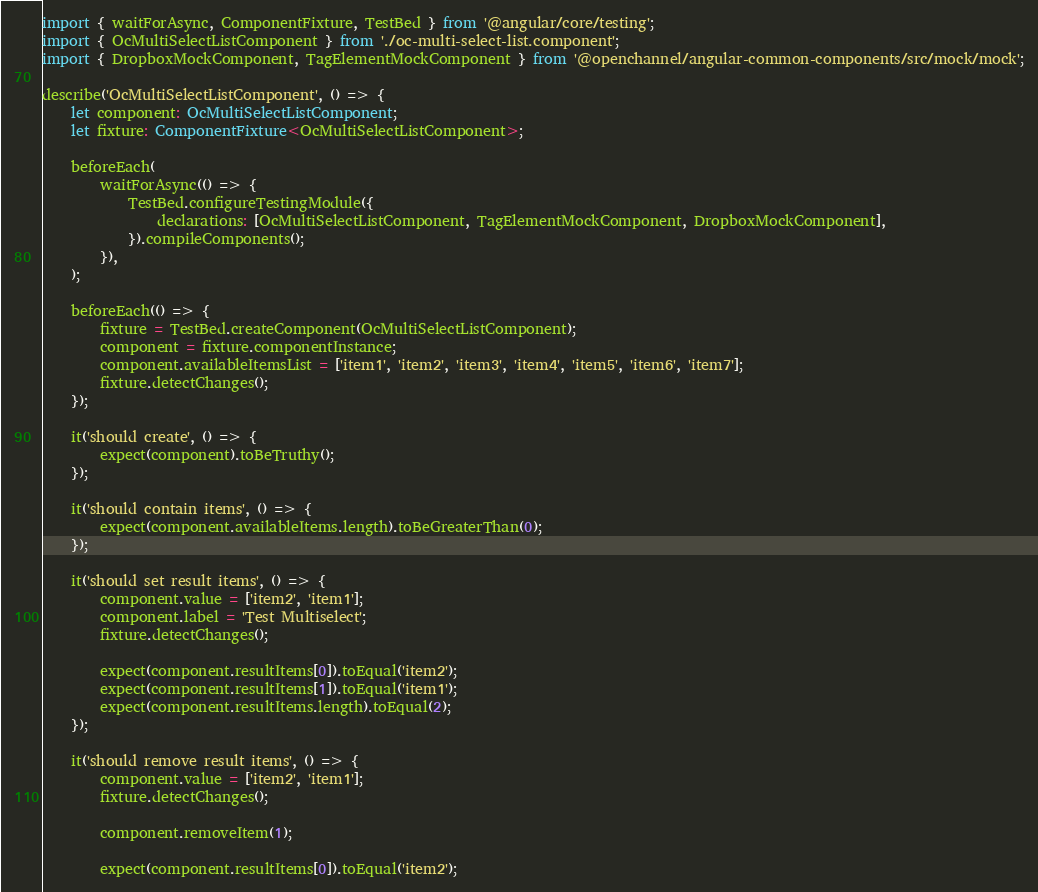<code> <loc_0><loc_0><loc_500><loc_500><_TypeScript_>import { waitForAsync, ComponentFixture, TestBed } from '@angular/core/testing';
import { OcMultiSelectListComponent } from './oc-multi-select-list.component';
import { DropboxMockComponent, TagElementMockComponent } from '@openchannel/angular-common-components/src/mock/mock';

describe('OcMultiSelectListComponent', () => {
    let component: OcMultiSelectListComponent;
    let fixture: ComponentFixture<OcMultiSelectListComponent>;

    beforeEach(
        waitForAsync(() => {
            TestBed.configureTestingModule({
                declarations: [OcMultiSelectListComponent, TagElementMockComponent, DropboxMockComponent],
            }).compileComponents();
        }),
    );

    beforeEach(() => {
        fixture = TestBed.createComponent(OcMultiSelectListComponent);
        component = fixture.componentInstance;
        component.availableItemsList = ['item1', 'item2', 'item3', 'item4', 'item5', 'item6', 'item7'];
        fixture.detectChanges();
    });

    it('should create', () => {
        expect(component).toBeTruthy();
    });

    it('should contain items', () => {
        expect(component.availableItems.length).toBeGreaterThan(0);
    });

    it('should set result items', () => {
        component.value = ['item2', 'item1'];
        component.label = 'Test Multiselect';
        fixture.detectChanges();

        expect(component.resultItems[0]).toEqual('item2');
        expect(component.resultItems[1]).toEqual('item1');
        expect(component.resultItems.length).toEqual(2);
    });

    it('should remove result items', () => {
        component.value = ['item2', 'item1'];
        fixture.detectChanges();

        component.removeItem(1);

        expect(component.resultItems[0]).toEqual('item2');</code> 